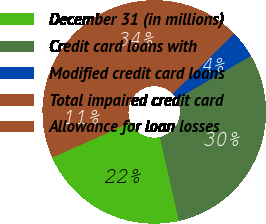Convert chart to OTSL. <chart><loc_0><loc_0><loc_500><loc_500><pie_chart><fcel>December 31 (in millions)<fcel>Credit card loans with<fcel>Modified credit card loans<fcel>Total impaired credit card<fcel>Allowance for loan losses<nl><fcel>21.85%<fcel>29.8%<fcel>4.0%<fcel>33.81%<fcel>10.54%<nl></chart> 